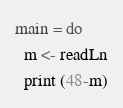<code> <loc_0><loc_0><loc_500><loc_500><_Haskell_>main = do
  m <- readLn
  print (48-m)</code> 